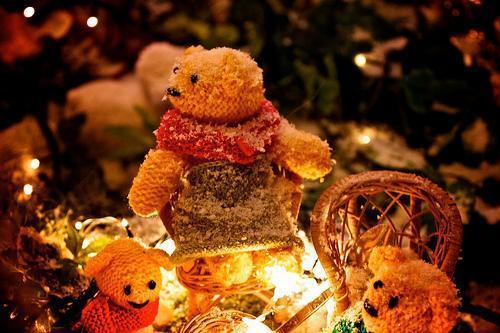How many stuffed animals have noses in the image?
Give a very brief answer. 2. 